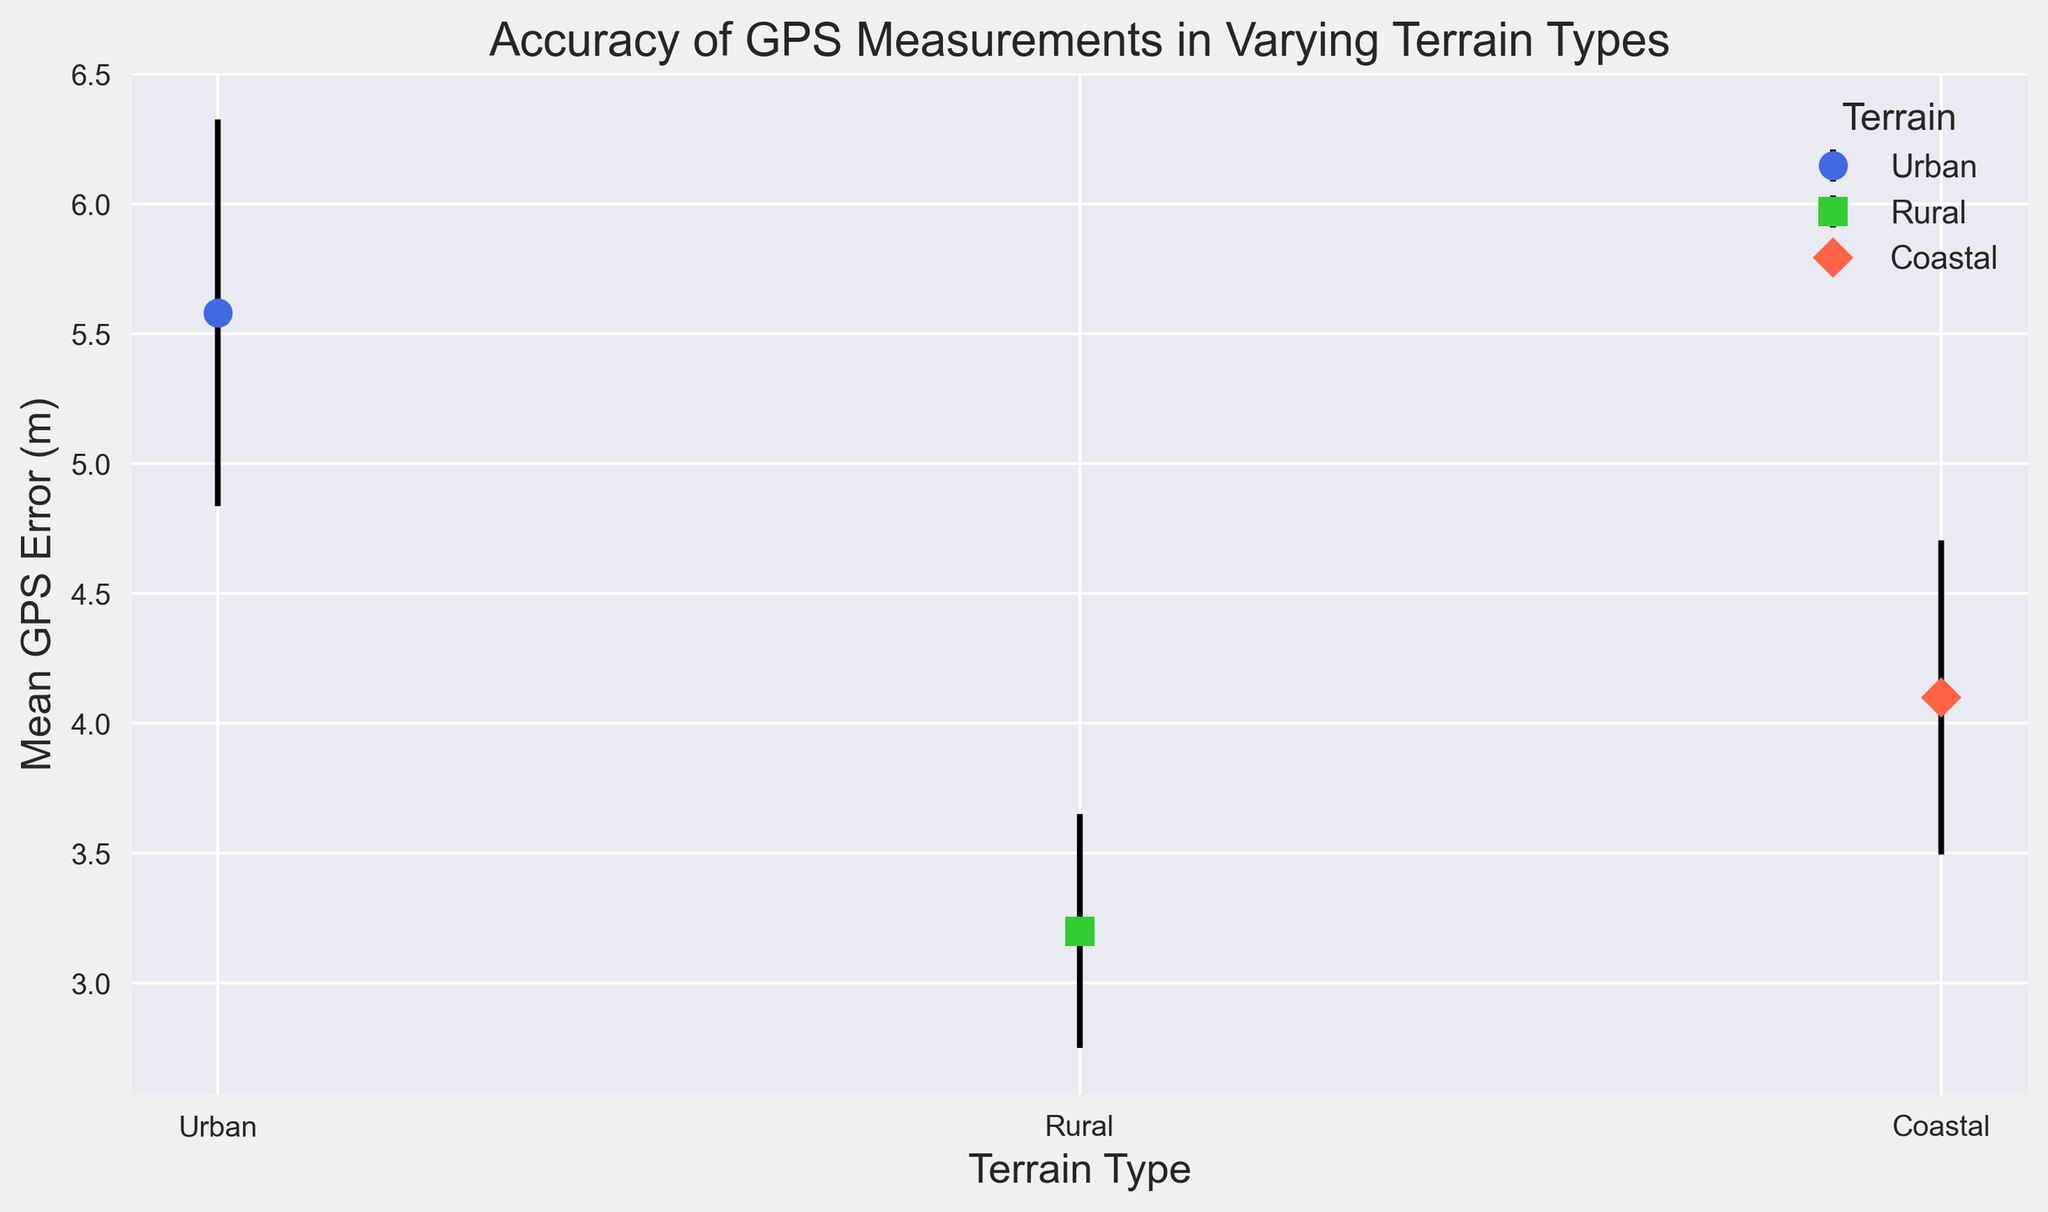What is the mean GPS error for urban terrain? Locate the mean GPS error value for urban terrain on the y-axis.
Answer: 5.58 meters Which terrain type has the lowest mean GPS error? Compare the mean GPS error values for urban, rural, and coastal terrains, and identify the lowest one.
Answer: Rural What is the difference in mean GPS error between urban and coastal terrains? Subtract the mean GPS error for coastal terrain from the mean GPS error for urban terrain (5.58 - 4.10).
Answer: 1.48 meters Which terrain type has the largest measurement uncertainty (error bars)? Observe the length of the error bars (standard deviation) for each terrain type and identify the terrain with the largest error bars.
Answer: Urban What is the average standard deviation across all terrain types? Calculate the average of the standard deviations for urban, rural, and coastal terrains ((0.74 + 0.45 + 0.60) / 3).
Answer: 0.60 meters How does the mean GPS error in coastal terrain compare to that in rural terrain? Compare the mean GPS error values for coastal and rural terrains. Coastal terrain has a higher mean GPS error than rural terrain (4.10 vs. 3.20).
Answer: Coastal terrain has a higher mean GPS error What is the combined mean GPS error for rural and coastal terrains? Add the mean GPS errors for rural and coastal terrains (3.20 + 4.10).
Answer: 7.30 meters Which marker shape represents coastal terrain? Look for the marker shape used to plot the data for coastal terrain in the figure.
Answer: Diamond (D) In which terrain type is the GPS measurement error most consistent (lowest standard deviation)? Identify the terrain type with the lowest average standard deviation value.
Answer: Rural How much higher is the mean GPS error in urban terrain compared to rural terrain? Subtract the mean GPS error for rural terrain from the mean GPS error for urban terrain (5.58 - 3.20).
Answer: 2.38 meters 